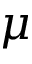<formula> <loc_0><loc_0><loc_500><loc_500>\mu</formula> 